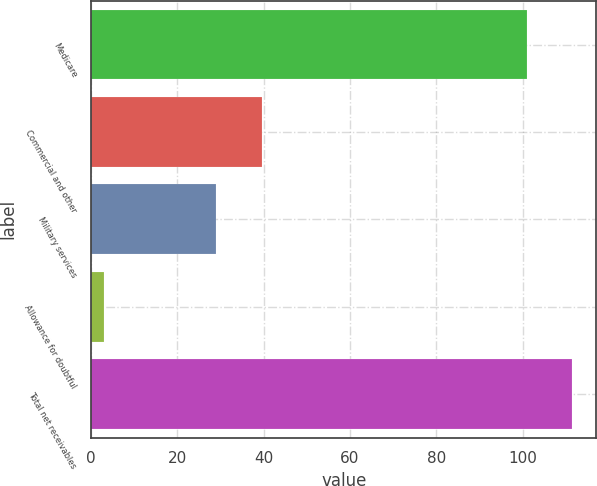<chart> <loc_0><loc_0><loc_500><loc_500><bar_chart><fcel>Medicare<fcel>Commercial and other<fcel>Military services<fcel>Allowance for doubtful<fcel>Total net receivables<nl><fcel>101<fcel>39.5<fcel>29<fcel>3<fcel>111.5<nl></chart> 